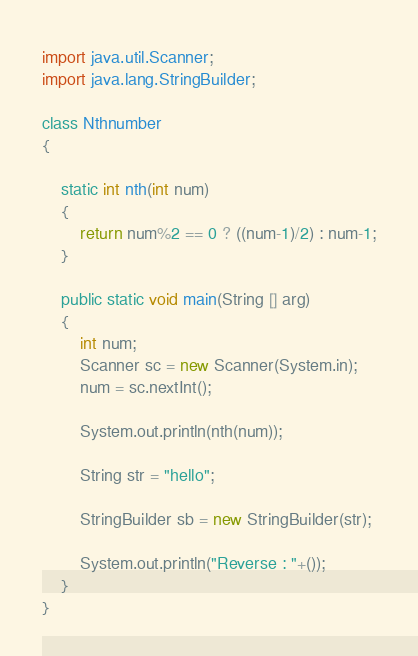<code> <loc_0><loc_0><loc_500><loc_500><_Java_>import java.util.Scanner;
import java.lang.StringBuilder;

class Nthnumber
{

	static int nth(int num)
	{
		return num%2 == 0 ? ((num-1)/2) : num-1;
	}

	public static void main(String [] arg)
	{
		int num;
		Scanner sc = new Scanner(System.in);
		num = sc.nextInt();
		
		System.out.println(nth(num));
		
		String str = "hello";
		
		StringBuilder sb = new StringBuilder(str);
		
		System.out.println("Reverse : "+());
	}
}
</code> 